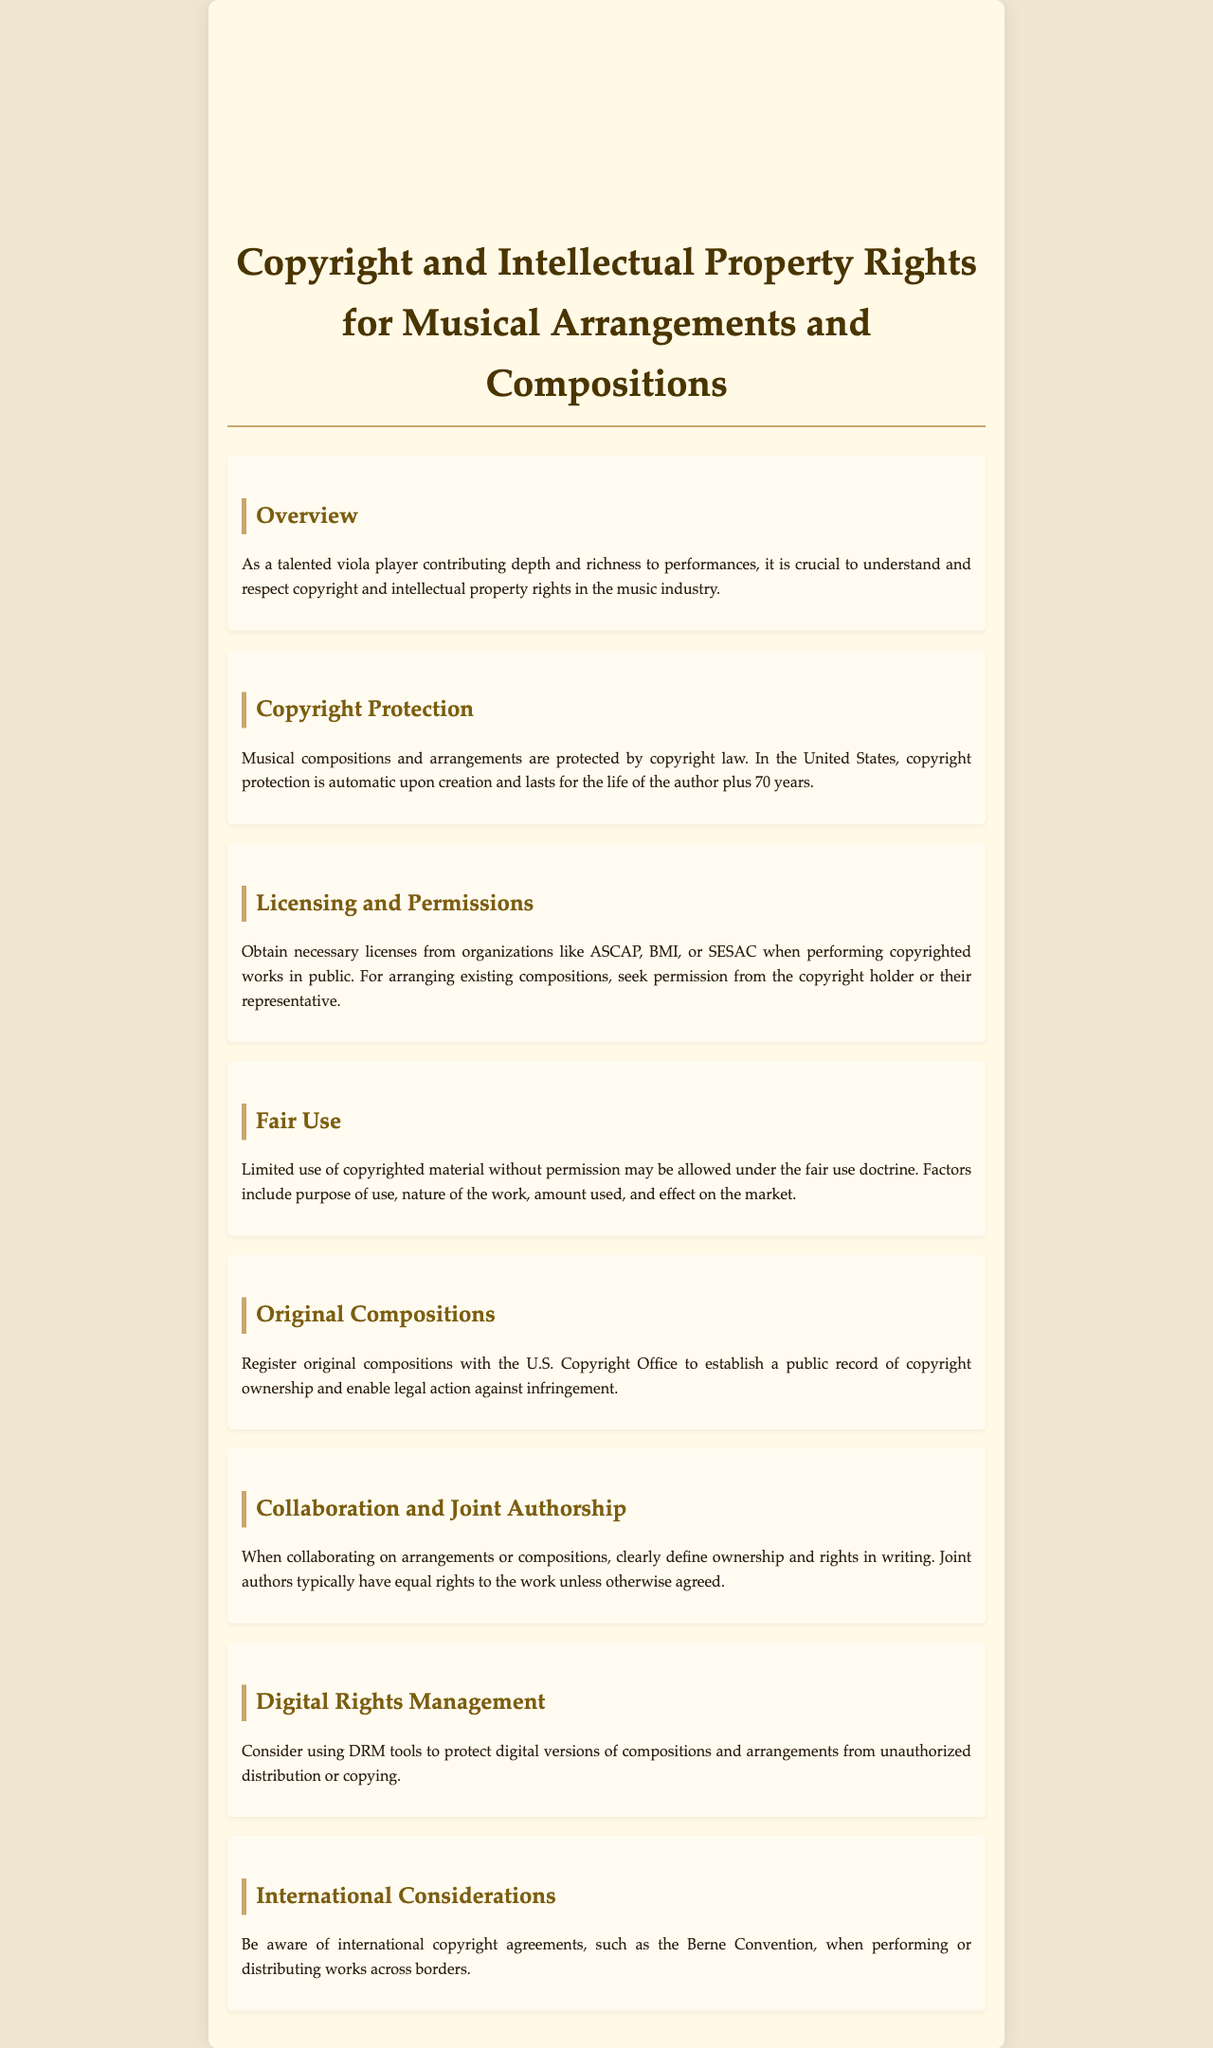What is the duration of copyright protection for musical compositions? Copyright protection lasts for the life of the author plus 70 years.
Answer: life of the author plus 70 years Who should be contacted for licenses when performing copyrighted works? Necessary licenses should be obtained from organizations like ASCAP, BMI, or SESAC.
Answer: ASCAP, BMI, or SESAC What doctrine allows limited use of copyrighted material without permission? The fair use doctrine allows limited use without permission.
Answer: fair use What should be done to protect original compositions legally? Register original compositions with the U.S. Copyright Office.
Answer: Register with the U.S. Copyright Office What must be clearly defined when collaborating on musical arrangements? Ownership and rights must be clearly defined in writing.
Answer: Ownership and rights Which international agreement should be considered for works distributed across borders? The Berne Convention is an important international agreement.
Answer: Berne Convention 